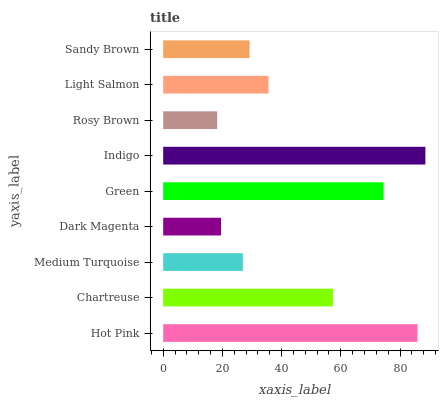Is Rosy Brown the minimum?
Answer yes or no. Yes. Is Indigo the maximum?
Answer yes or no. Yes. Is Chartreuse the minimum?
Answer yes or no. No. Is Chartreuse the maximum?
Answer yes or no. No. Is Hot Pink greater than Chartreuse?
Answer yes or no. Yes. Is Chartreuse less than Hot Pink?
Answer yes or no. Yes. Is Chartreuse greater than Hot Pink?
Answer yes or no. No. Is Hot Pink less than Chartreuse?
Answer yes or no. No. Is Light Salmon the high median?
Answer yes or no. Yes. Is Light Salmon the low median?
Answer yes or no. Yes. Is Medium Turquoise the high median?
Answer yes or no. No. Is Sandy Brown the low median?
Answer yes or no. No. 